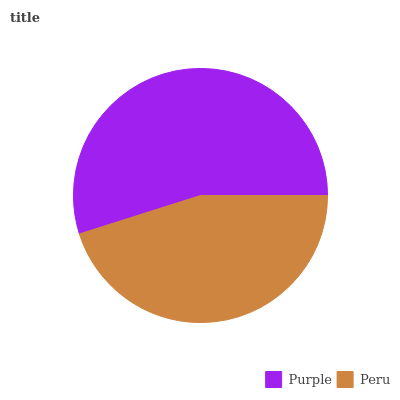Is Peru the minimum?
Answer yes or no. Yes. Is Purple the maximum?
Answer yes or no. Yes. Is Peru the maximum?
Answer yes or no. No. Is Purple greater than Peru?
Answer yes or no. Yes. Is Peru less than Purple?
Answer yes or no. Yes. Is Peru greater than Purple?
Answer yes or no. No. Is Purple less than Peru?
Answer yes or no. No. Is Purple the high median?
Answer yes or no. Yes. Is Peru the low median?
Answer yes or no. Yes. Is Peru the high median?
Answer yes or no. No. Is Purple the low median?
Answer yes or no. No. 